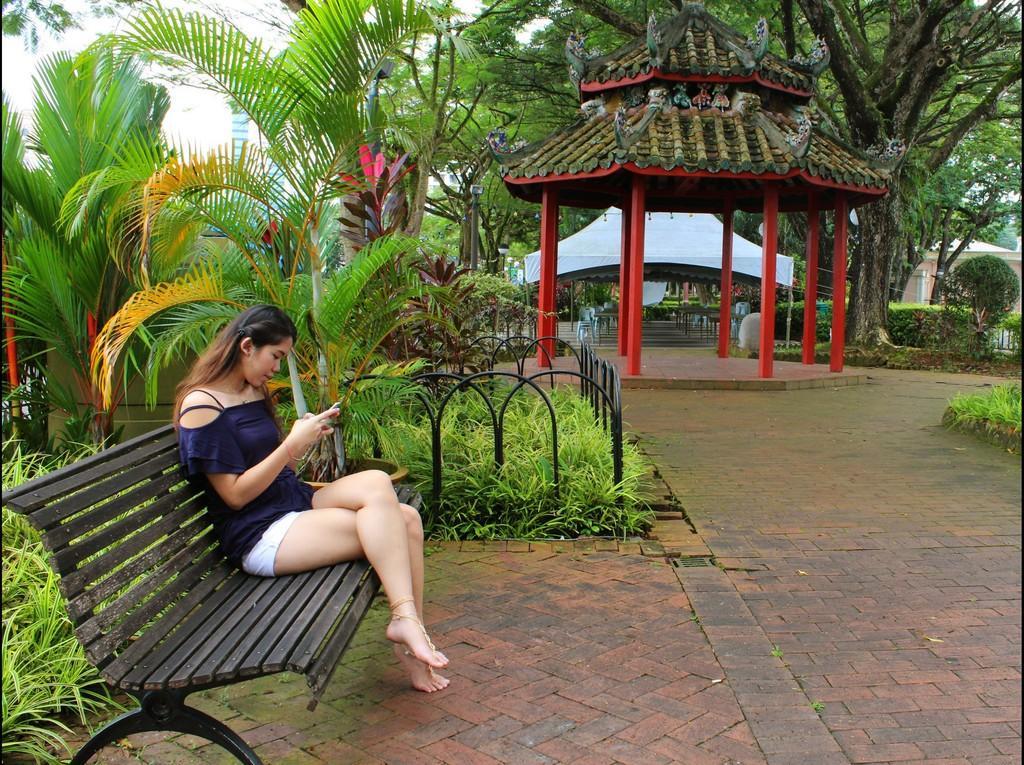Can you describe this image briefly? In this picture we can see woman looking at mobile holding in her hand and sitting on bench and bedside to her we can see trees, fence and in background we can see some hut, trees, path. 